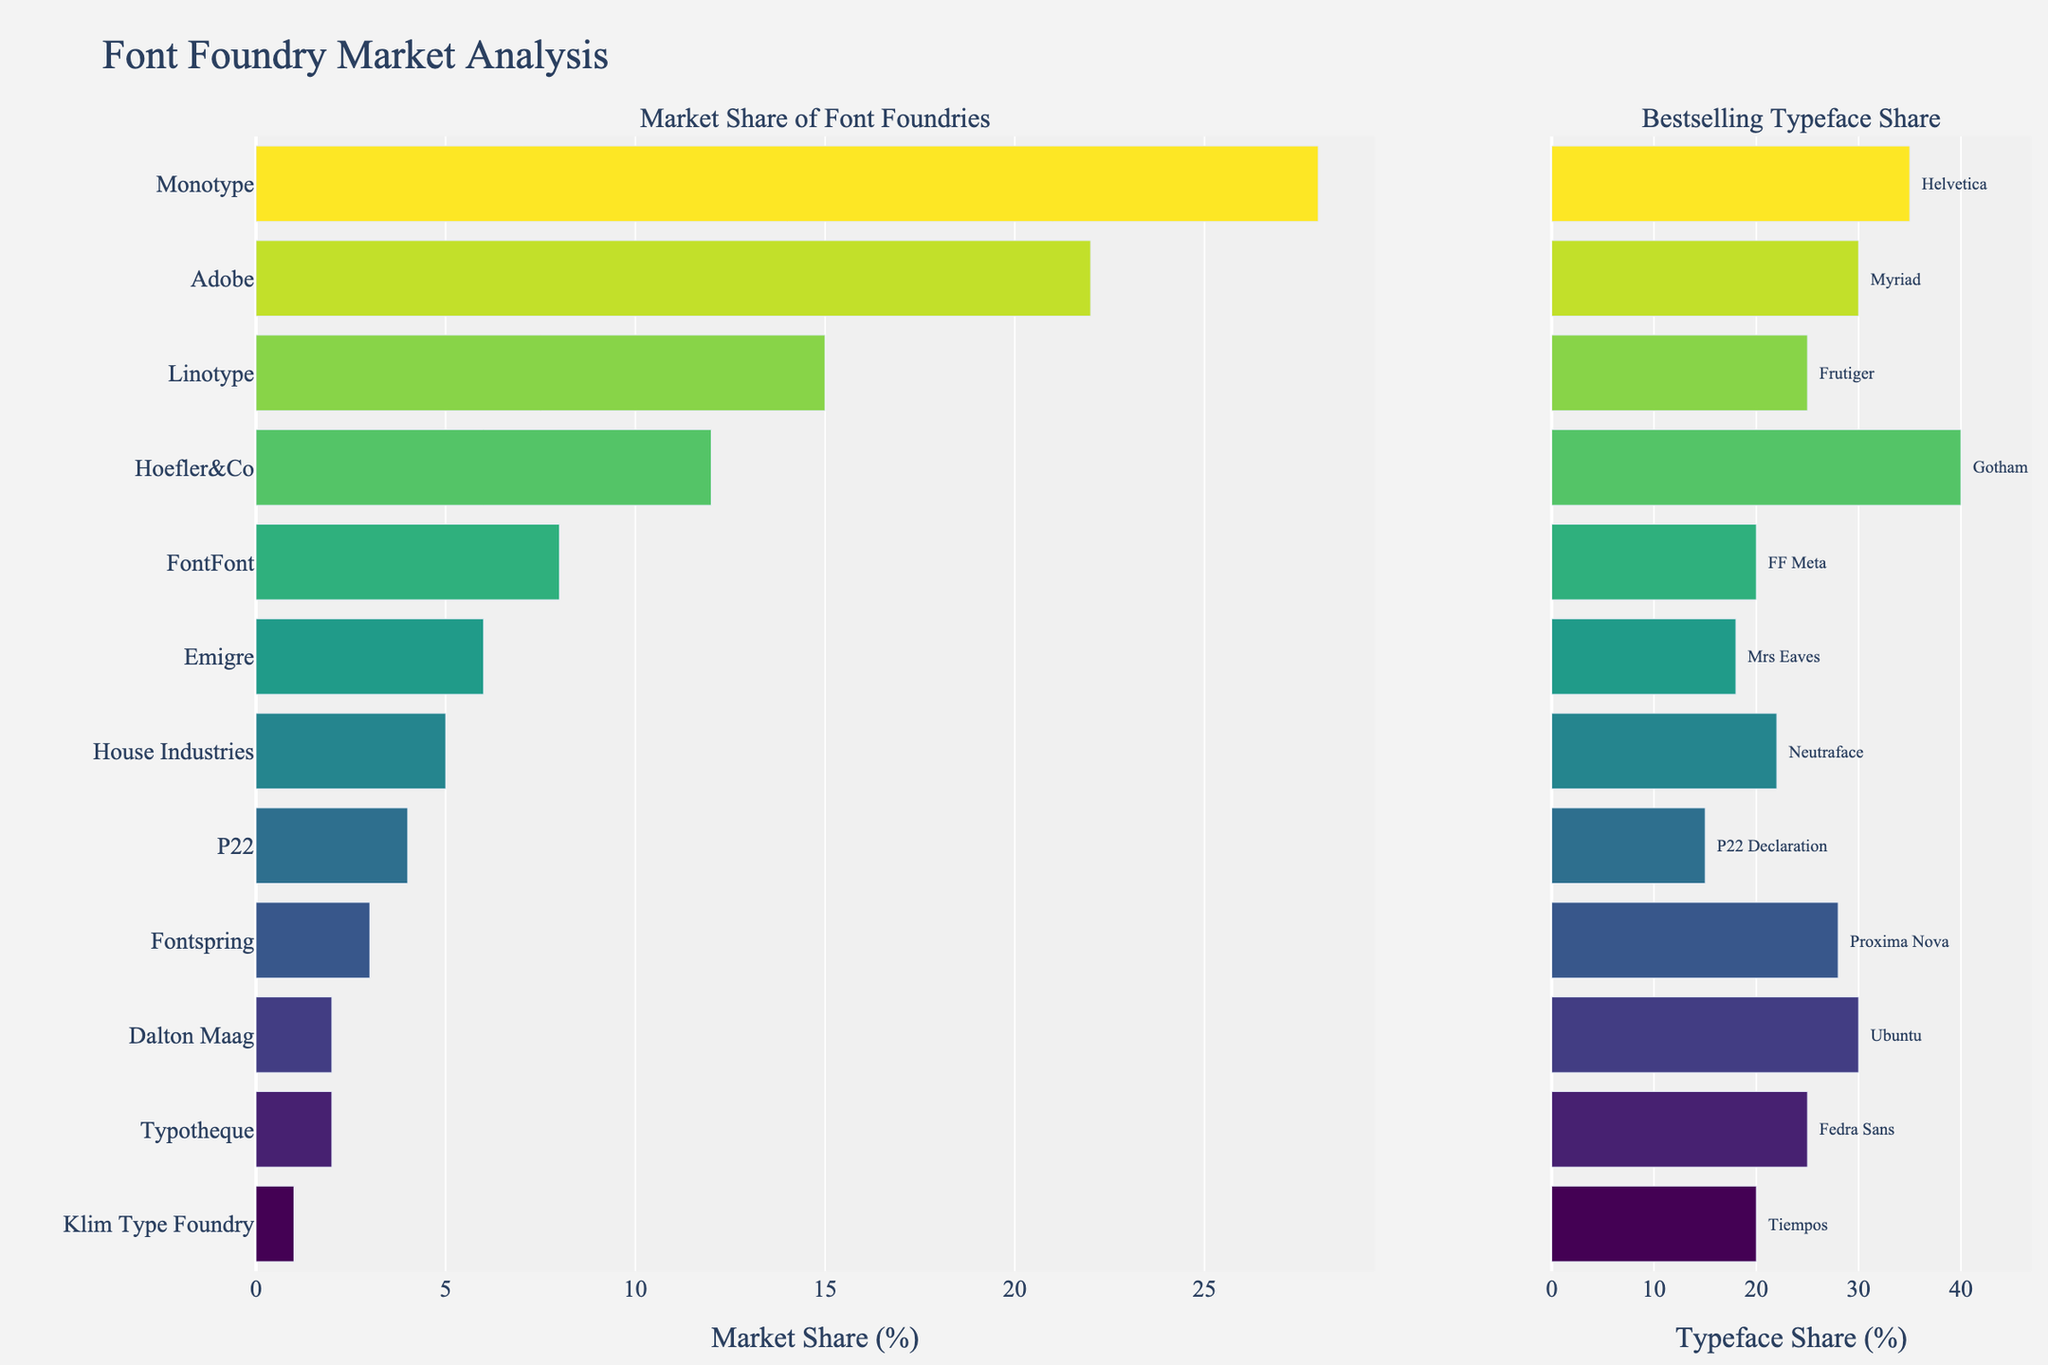Which foundry has the highest market share? The foundry with the highest market share is identified by the height of its bar in the "Market Share of Font Foundries" subplot. Monotype has the tallest bar, indicating it holds the largest market share.
Answer: Monotype Which bestselling typeface has the highest share within its foundry? The bestselling typeface with the highest share within its foundry is identified by the highest bar in the "Bestselling Typeface Share" subplot. Gotham by Hoefler&Co has the highest typeface share of 40%.
Answer: Gotham What is the difference in market share between Adobe and Linotype? To find the difference in market share, subtract Linotype's market share from Adobe's. Adobe has 22% and Linotype has 15%. So, 22% - 15% = 7%.
Answer: 7% Which foundry has the smallest difference between its market share and its bestselling typeface share? Compare the difference between the market share and typeface share for each foundry. P22 has a market share of 4% and a typeface share of 15%. The difference is 11%, which is the smallest among the foundries listed.
Answer: P22 What is the combined market share of Fontspring, Typotheque, and Dalton Maag? Add the market shares of Fontspring, Typotheque, and Dalton Maag. Fontspring has 3%, Typotheque has 2%, and Dalton Maag has 2%. So, 3% + 2% + 2% = 7%.
Answer: 7% How much higher is Monotype's market share compared to House Industries? Subtract House Industries' market share from Monotype's market share. Monotype has 28% and House Industries has 5%. So, 28% - 5% = 23%.
Answer: 23% Which foundry's bestselling typeface has the smallest share within its foundry? The smallest share of a bestselling typeface within its foundry is indicated by the smallest bar in the "Bestselling Typeface Share" subplot. P22 Declaration by P22 has the smallest typeface share of 15%.
Answer: P22 Declaration How many foundries have a market share above 10%? Count the number of foundries with market share percentages above 10% in the "Market Share of Font Foundries" subplot. Monotype (28%), Adobe (22%), Linotype (15%), and Hoefler&Co (12%) are above 10%. There are 4 foundries.
Answer: 4 